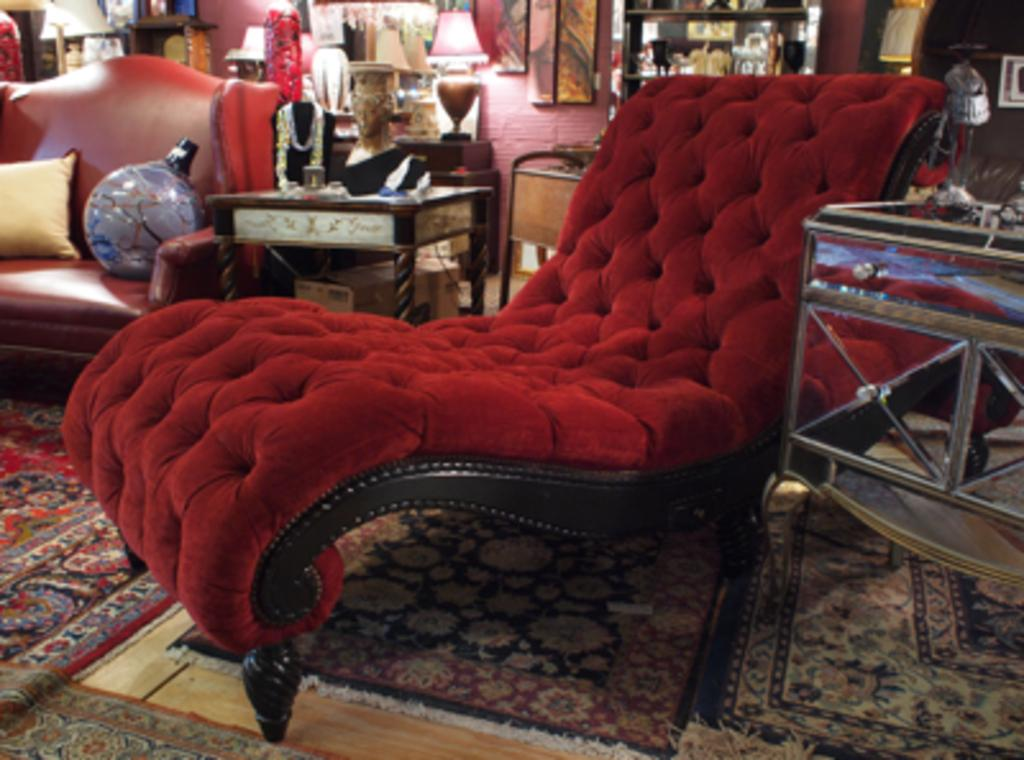What piece of furniture is located in the center of the image? There is a chair in the center of the image. What other piece of furniture can be seen in the image? There is a couch in the image. What is on the couch? There is a pillow and a globe on the couch. What can be seen on the walls in the image? There is a wall visible in the image. What type of furniture is present in the image for holding objects? There are tables in the image. What is on the tables? There are objects on the tables. What type of decorative item is present in the image? There is a frame in the image. What other objects are around the couch and chair? There are additional objects around the couch and chair. Can you tell me how many snakes are slithering on the chair in the image? There are no snakes present in the image; it only features furniture and decorative items. What type of butter is being used to clean the objects on the tables in the image? There is no butter present in the image, and the objects on the tables are not being cleaned. 